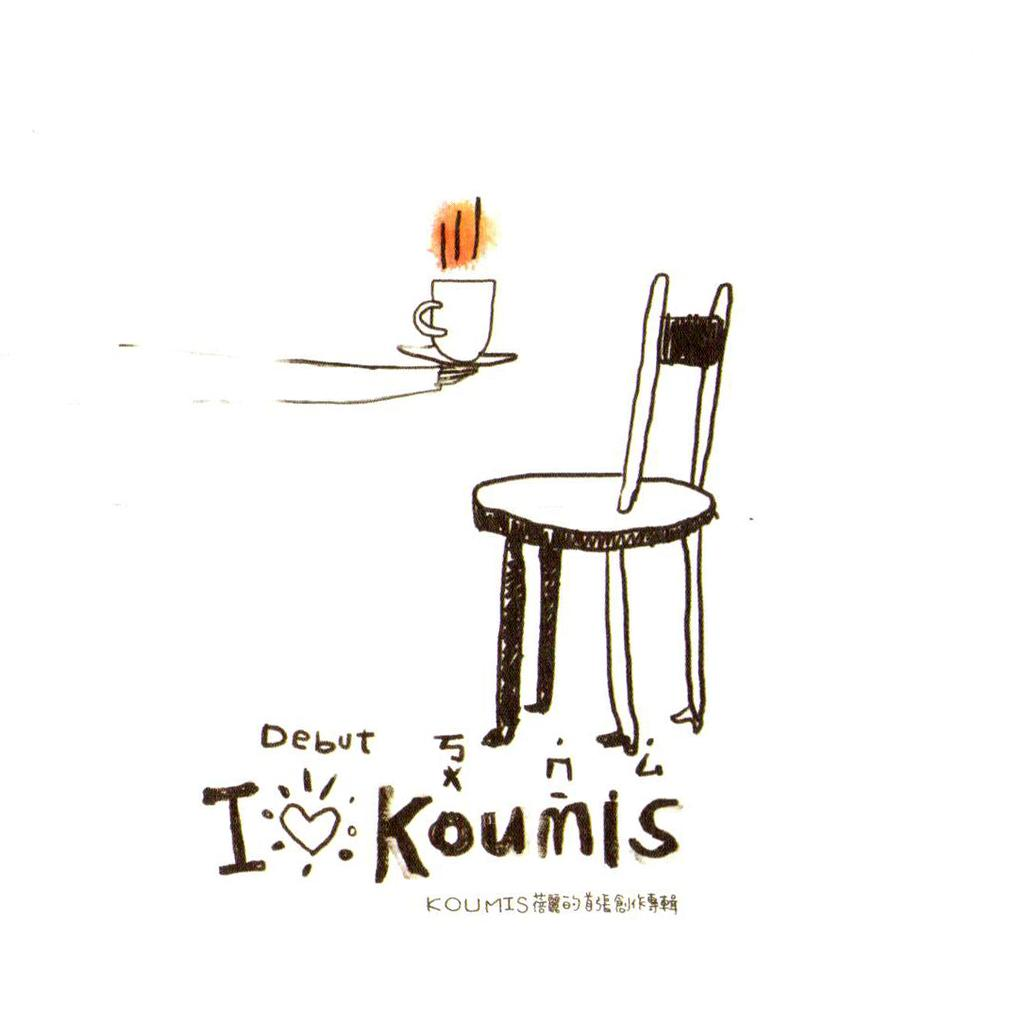What style is the image drawn in? The image is a cartoon sketch. What piece of furniture is present in the image? There is a chair in the image. What is the person in the image holding? A person's hand is holding a cup in the image. What is written on the cup? The text "debut GIAKOUMIS" is written on the cup. What type of pin is holding the cup to the chair in the image? There is no pin holding the cup to the chair in the image; it is being held by a person's hand. What cause is the person in the image advocating for? The image does not provide any information about a cause the person might be advocating for. 